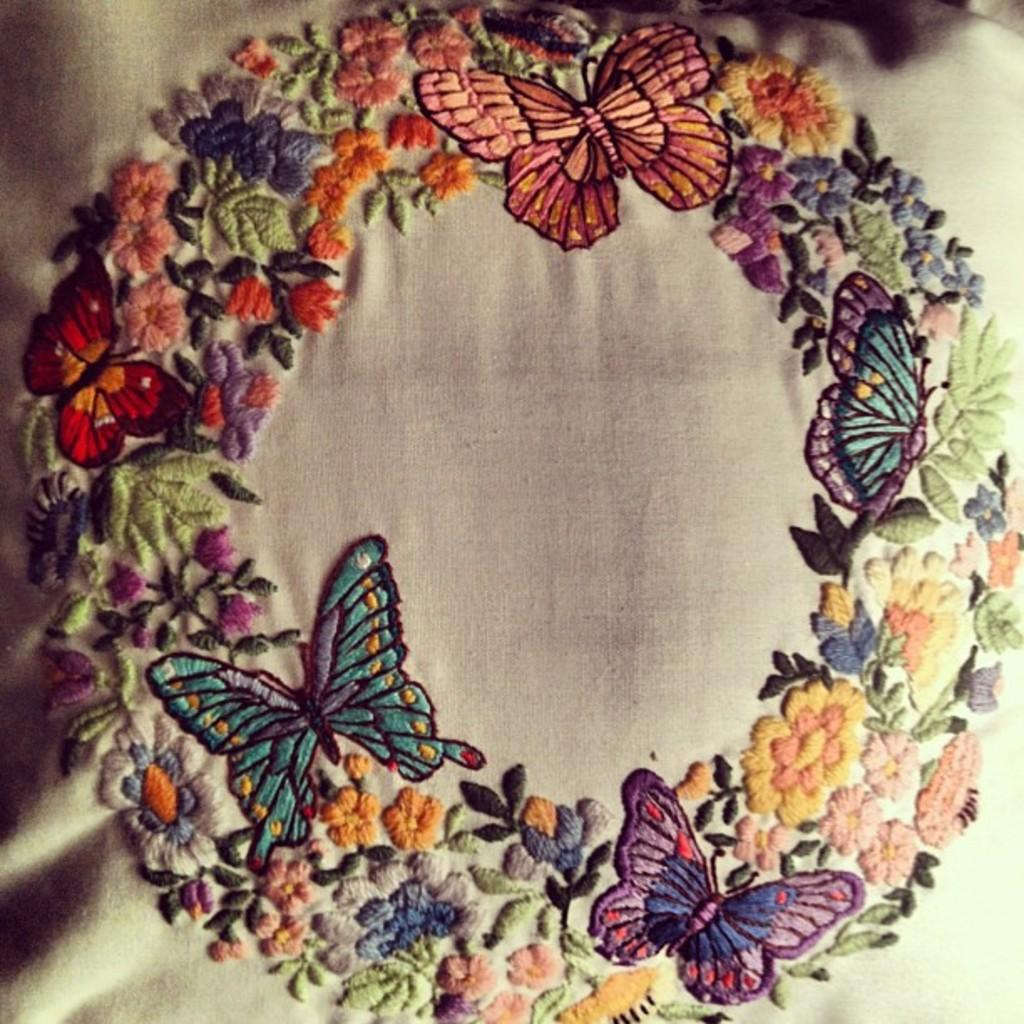What is the main subject of the image? The main subject of the image is a colorful embroidery design. What types of elements are included in the design? The design features butterflies and flowers. What material is the design on? The design is on a cloth. Can you see a boat in the embroidery design? No, there is no boat present in the embroidery design. Is there a kitty included in the design? No, there is no kitty included in the embroidery design; it features butterflies and flowers. 